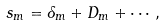<formula> <loc_0><loc_0><loc_500><loc_500>s _ { m } = \delta _ { m } + D _ { m } + \cdots \, ,</formula> 